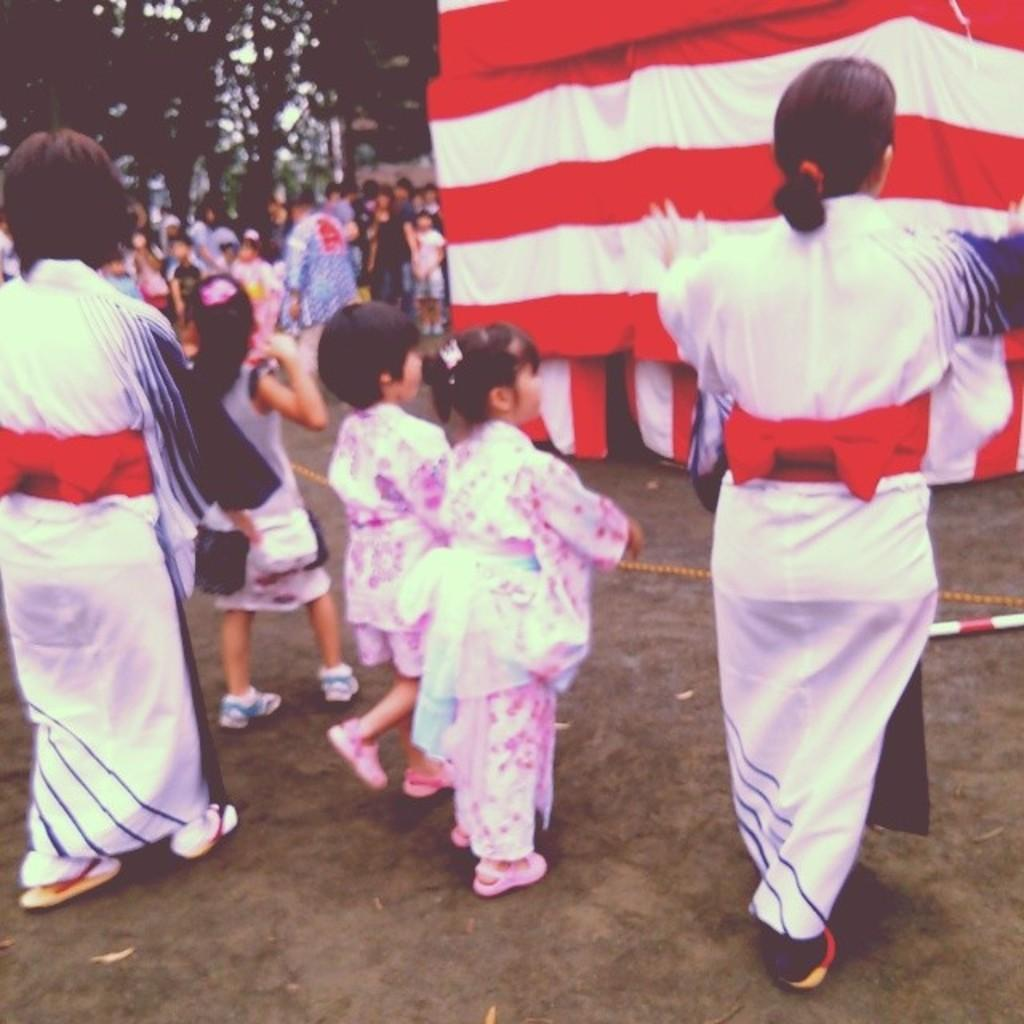How many people are in the group visible in the image? There is a group of people in the image, but the exact number cannot be determined without more specific information. What is located in the background of the image? There is a tent and trees in the background of the image. What type of legal advice can be obtained from the potato in the image? There is no potato present in the image, and therefore no legal advice can be obtained from it. 